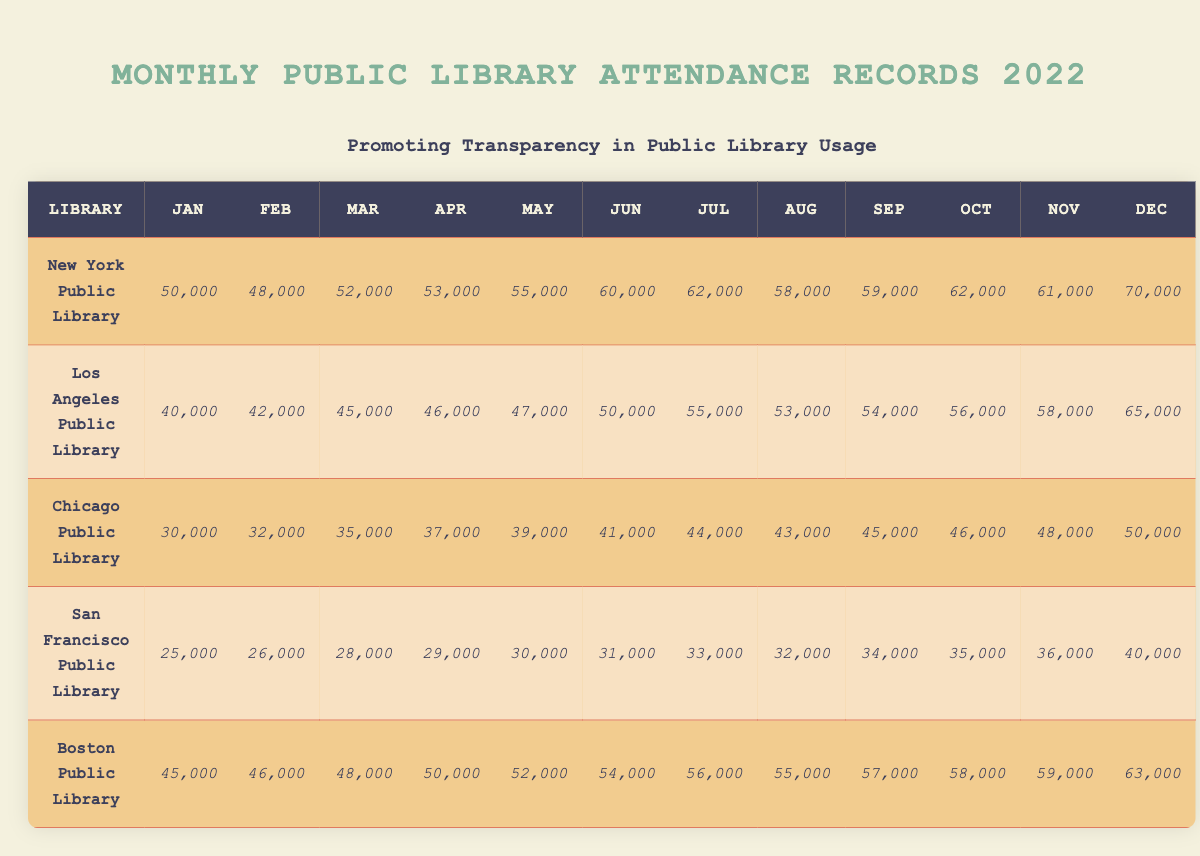What is the total attendance for the New York Public Library in December? From the table, the attendance for the New York Public Library in December is listed as 70,000.
Answer: 70,000 Which library had the highest monthly attendance in July? The table shows that the New York Public Library had an attendance of 62,000 in July, while other libraries had lower numbers (Los Angeles: 55,000, Chicago: 44,000, San Francisco: 33,000, Boston: 56,000). Therefore, New York Public Library has the highest attendance in July.
Answer: New York Public Library What was the average monthly attendance for the Boston Public Library? First, sum the monthly attendances: (45,000 + 46,000 + 48,000 + 50,000 + 52,000 + 54,000 + 56,000 + 55,000 + 57,000 + 58,000 + 59,000 + 63,000) =  663,000. Then divide by 12 (number of months): 663,000 / 12 = 55,250.
Answer: 55,250 Is the attendance in March for the Los Angeles Public Library greater than 45,000? The table shows the attendance for March at 45,000 for Los Angeles Public Library, so it is not greater; it is equal.
Answer: No What is the increase in attendance from January to July for the Chicago Public Library? The attendance in January is 30,000 and in July it is 44,000. To find the increase, subtract January's attendance from July's: 44,000 - 30,000 = 14,000.
Answer: 14,000 Which library had the lowest total attendance over the year? To find this, we sum the monthly attendance for each library and compare them. The San Francisco Public Library has the lowest total attendance of  30,000 + 31,000 + 32,000 + 33,000 + 34,000 + 35,000 + 36,000 + 40,000 =  296,000.
Answer: San Francisco Public Library What was the percentage increase in attendance for the New York Public Library from January to December? The attendance in January was 50,000 and in December it was 70,000. The increase is 70,000 - 50,000 = 20,000. To find the percentage increase: (20,000 / 50,000) * 100 = 40%.
Answer: 40% Did the San Francisco Public Library have more than 30,000 attendees in every month? Looking at the table, in January (25,000) and February (26,000) the attendance was below 30,000. Therefore, they did not surpass 30,000 in those months.
Answer: No What is the difference in attendance between the Chicago Public Library in December and January? The attendance in December is 50,000 and in January is 30,000. The difference is: 50,000 - 30,000 = 20,000.
Answer: 20,000 Which months did the attendance for the Los Angeles Public Library exceed 50,000? From the table, the months where attendance exceeded 50,000 are July (55,000), August (53,000), September (54,000), October (56,000), November (58,000), and December (65,000).
Answer: July, August, September, October, November, December 